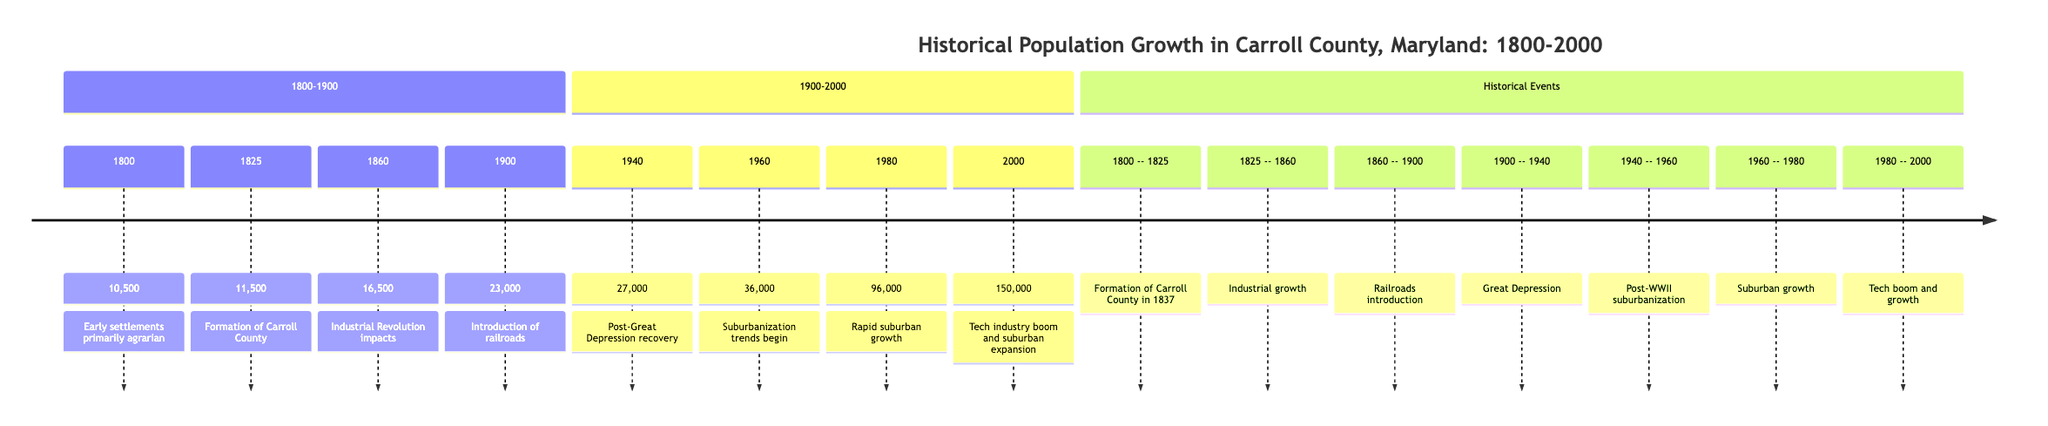What was the population of Carroll County in 1800? The diagram states the population in 1800 was 10,500. This information is explicitly provided at the corresponding node.
Answer: 10,500 What significant event occurred in 1825? The annotation at the 1825 node indicates the formation of Carroll County. This specific information is directly available next to that year.
Answer: Formation of Carroll County What was the population change from 1860 to 1900? By analyzing the population figures from the diagram, the population in 1860 was 16,500 and in 1900 was 23,000. The change is calculated as 23,000 - 16,500 = 6,500.
Answer: 6,500 How did the population of Carroll County change between 1940 and 1960? The population in 1940 was 27,000 and in 1960 it was 36,000. The increase is determined by subtracting the 1940 population from the 1960 population: 36,000 - 27,000 = 9,000.
Answer: 9,000 What event correlates with the population increase seen in 1980? The section notes the "Tech industry boom and suburban expansion" which occurred during the 1980s and resulted in a spike in population. The link between this event and the population growth is evident in the annotations.
Answer: Tech industry boom and suburban expansion What year showed the largest population increase in Carroll County between 1900 and 2000? To find the largest increase, we compare the population values: 1900 - 23,000, 1940 - 27,000, 1960 - 36,000, 1980 - 96,000, and 2000 - 150,000. The largest increase from previous years is from 1980 (96,000) to 2000 (150,000) which is 54,000.
Answer: 54,000 What major trend began in 1960? According to the diagram, the annotation mentions "Suburbanization trends begin" next to the 1960 entry. This indicates a significant societal trend initiated during that year.
Answer: Suburbanization trends begin What period saw the introduction of railroads affecting population growth? The section between 1860 and 1900 is labeled with the introduction of railroads, which is a key factor affecting growth during that period. The relevant annotation confirms this association.
Answer: 1860 - 1900 What is the total population of Carroll County in 2000? The diagram clearly states that the population in 2000 was 150,000, which is specified at the final node of the timeline.
Answer: 150,000 